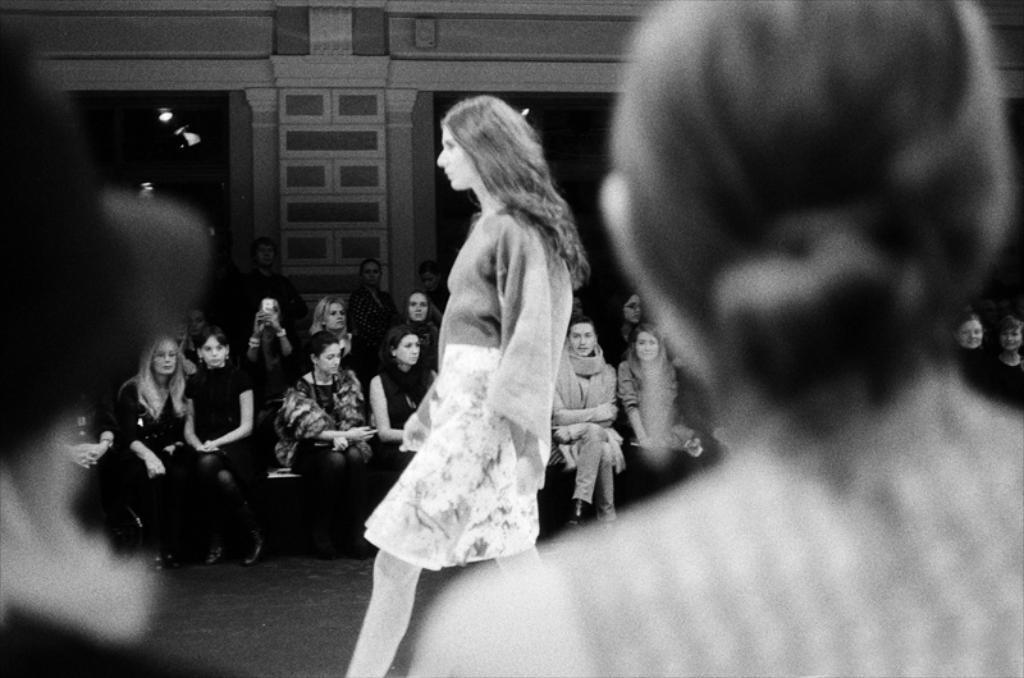Can you describe this image briefly? In this image I can see a woman is walking. Back Side I can see few people are sitting. One person is holding camera. I can see building and lights. 